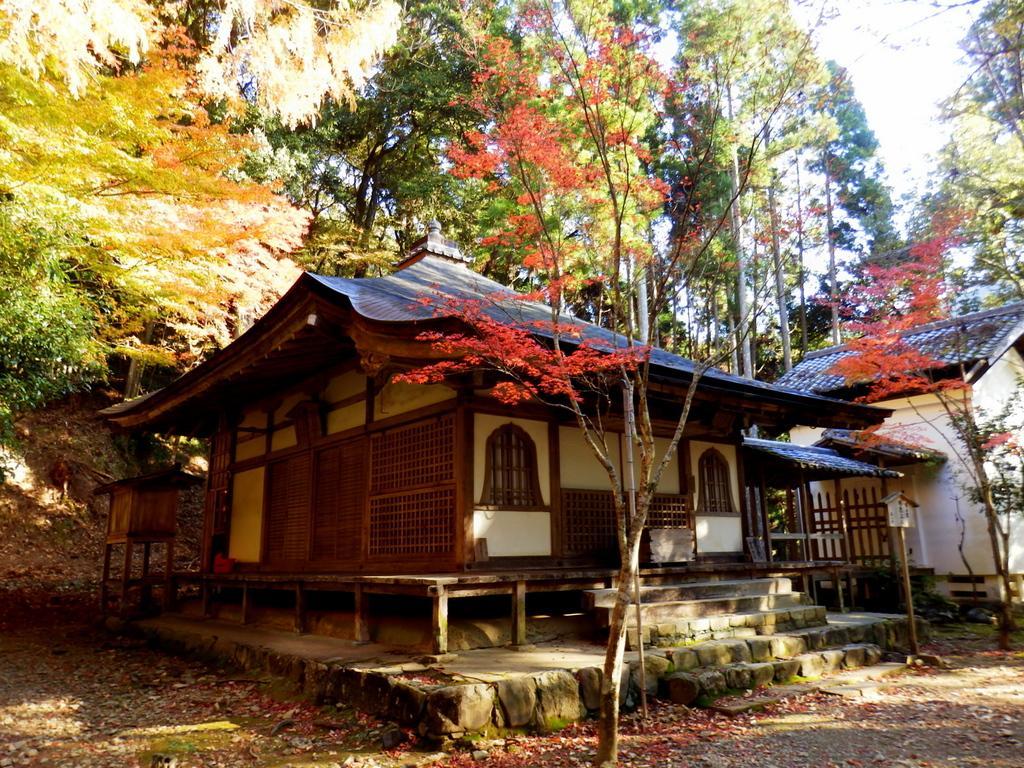Please provide a concise description of this image. In the front of the image there are trees, houses and objects. In the background of the image there are trees and sky. 